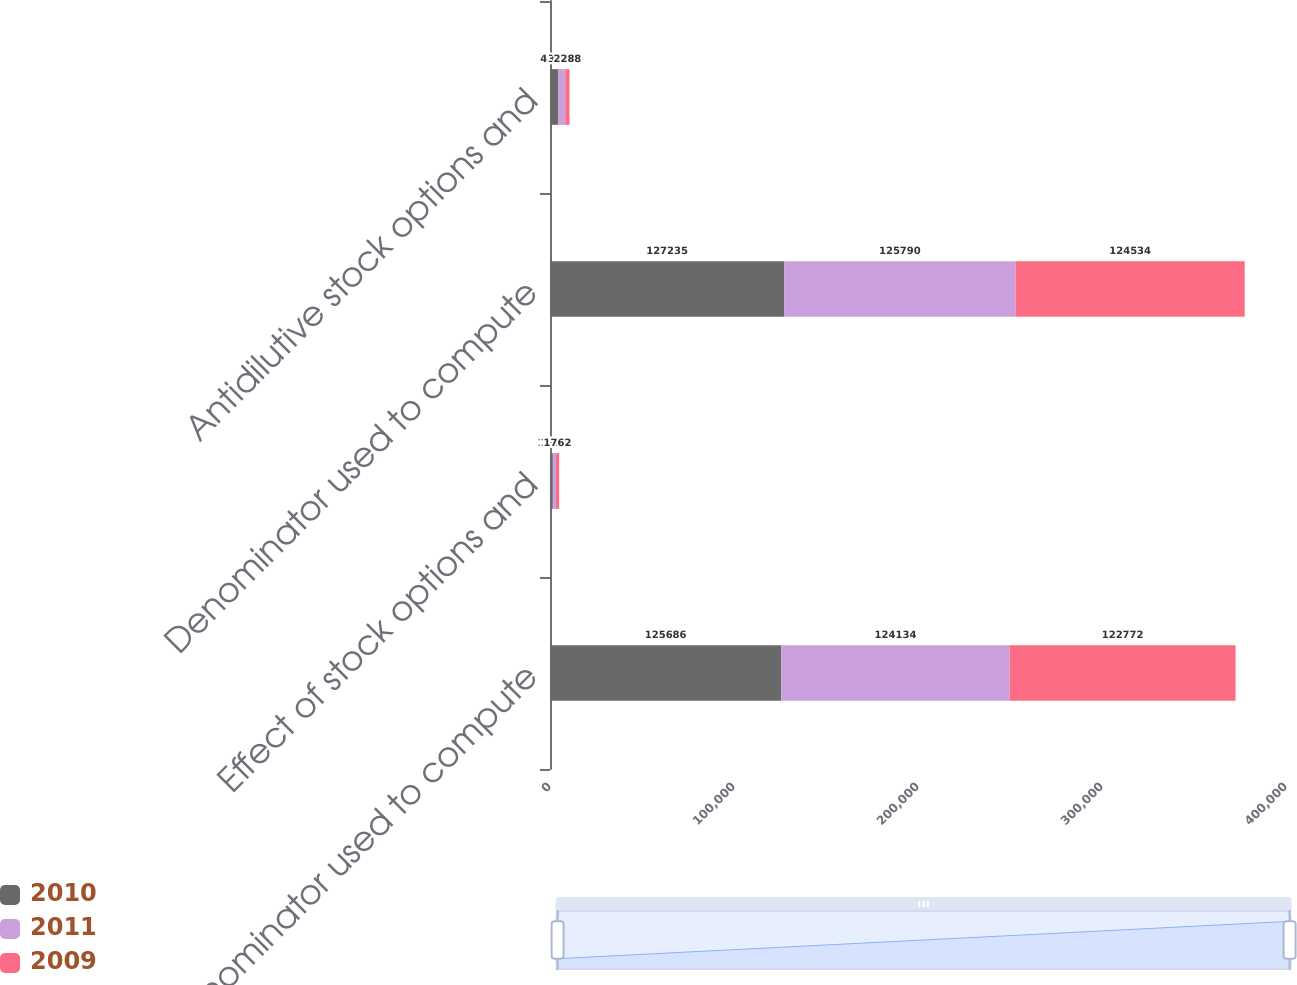Convert chart to OTSL. <chart><loc_0><loc_0><loc_500><loc_500><stacked_bar_chart><ecel><fcel>(denominator used to compute<fcel>Effect of stock options and<fcel>Denominator used to compute<fcel>Antidilutive stock options and<nl><fcel>2010<fcel>125686<fcel>1549<fcel>127235<fcel>4507<nl><fcel>2011<fcel>124134<fcel>1656<fcel>125790<fcel>3814<nl><fcel>2009<fcel>122772<fcel>1762<fcel>124534<fcel>2288<nl></chart> 